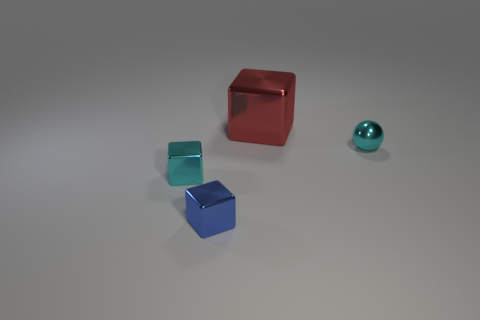Add 1 balls. How many objects exist? 5 Subtract all blocks. How many objects are left? 1 Subtract all small cyan shiny cubes. Subtract all small blue shiny things. How many objects are left? 2 Add 1 red objects. How many red objects are left? 2 Add 1 large gray shiny blocks. How many large gray shiny blocks exist? 1 Subtract 0 brown balls. How many objects are left? 4 